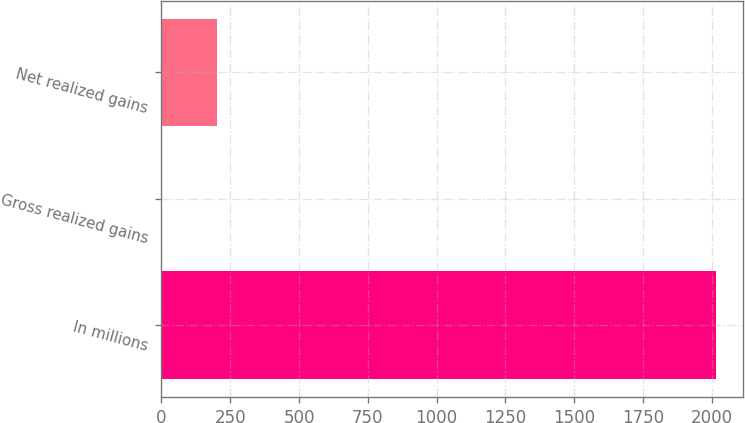<chart> <loc_0><loc_0><loc_500><loc_500><bar_chart><fcel>In millions<fcel>Gross realized gains<fcel>Net realized gains<nl><fcel>2014<fcel>0.6<fcel>201.94<nl></chart> 